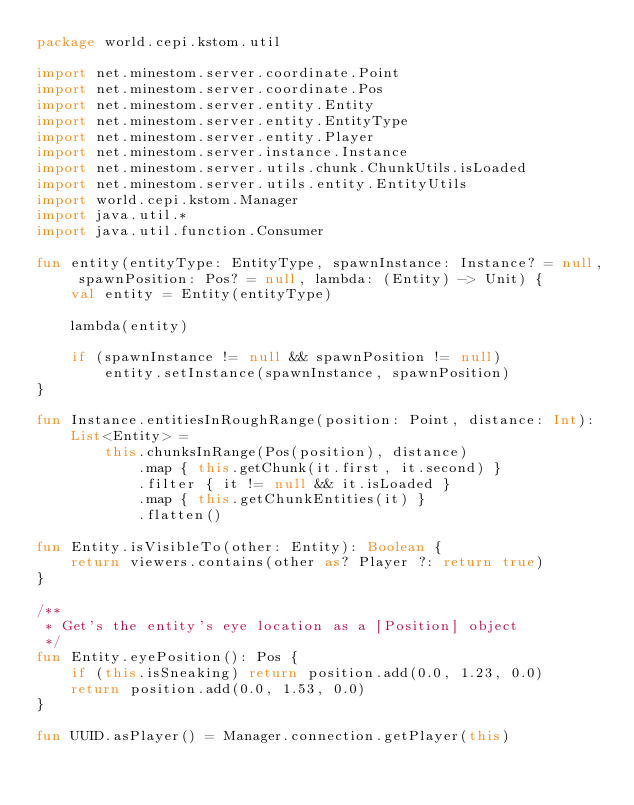<code> <loc_0><loc_0><loc_500><loc_500><_Kotlin_>package world.cepi.kstom.util

import net.minestom.server.coordinate.Point
import net.minestom.server.coordinate.Pos
import net.minestom.server.entity.Entity
import net.minestom.server.entity.EntityType
import net.minestom.server.entity.Player
import net.minestom.server.instance.Instance
import net.minestom.server.utils.chunk.ChunkUtils.isLoaded
import net.minestom.server.utils.entity.EntityUtils
import world.cepi.kstom.Manager
import java.util.*
import java.util.function.Consumer

fun entity(entityType: EntityType, spawnInstance: Instance? = null, spawnPosition: Pos? = null, lambda: (Entity) -> Unit) {
    val entity = Entity(entityType)

    lambda(entity)

    if (spawnInstance != null && spawnPosition != null)
        entity.setInstance(spawnInstance, spawnPosition)
}

fun Instance.entitiesInRoughRange(position: Point, distance: Int): List<Entity> =
        this.chunksInRange(Pos(position), distance)
            .map { this.getChunk(it.first, it.second) }
            .filter { it != null && it.isLoaded }
            .map { this.getChunkEntities(it) }
            .flatten()
    
fun Entity.isVisibleTo(other: Entity): Boolean {
    return viewers.contains(other as? Player ?: return true)
}

/**
 * Get's the entity's eye location as a [Position] object
 */
fun Entity.eyePosition(): Pos {
    if (this.isSneaking) return position.add(0.0, 1.23, 0.0)
    return position.add(0.0, 1.53, 0.0)
}

fun UUID.asPlayer() = Manager.connection.getPlayer(this)</code> 